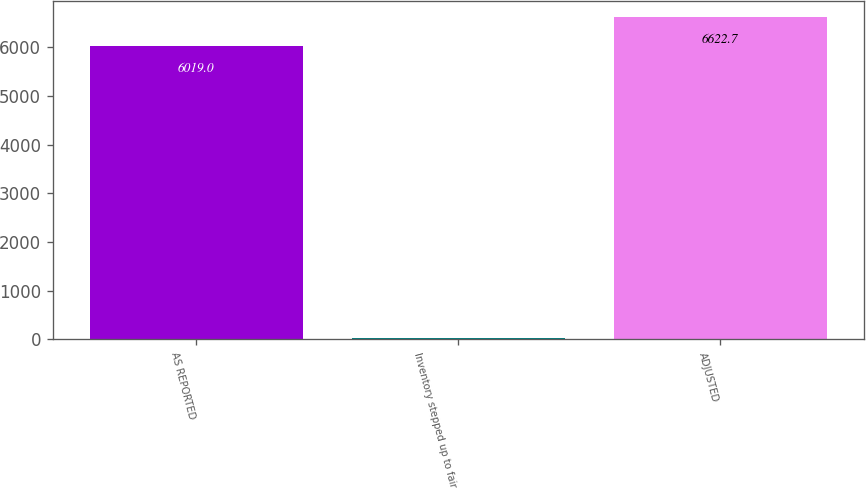Convert chart. <chart><loc_0><loc_0><loc_500><loc_500><bar_chart><fcel>AS REPORTED<fcel>Inventory stepped up to fair<fcel>ADJUSTED<nl><fcel>6019<fcel>28<fcel>6622.7<nl></chart> 